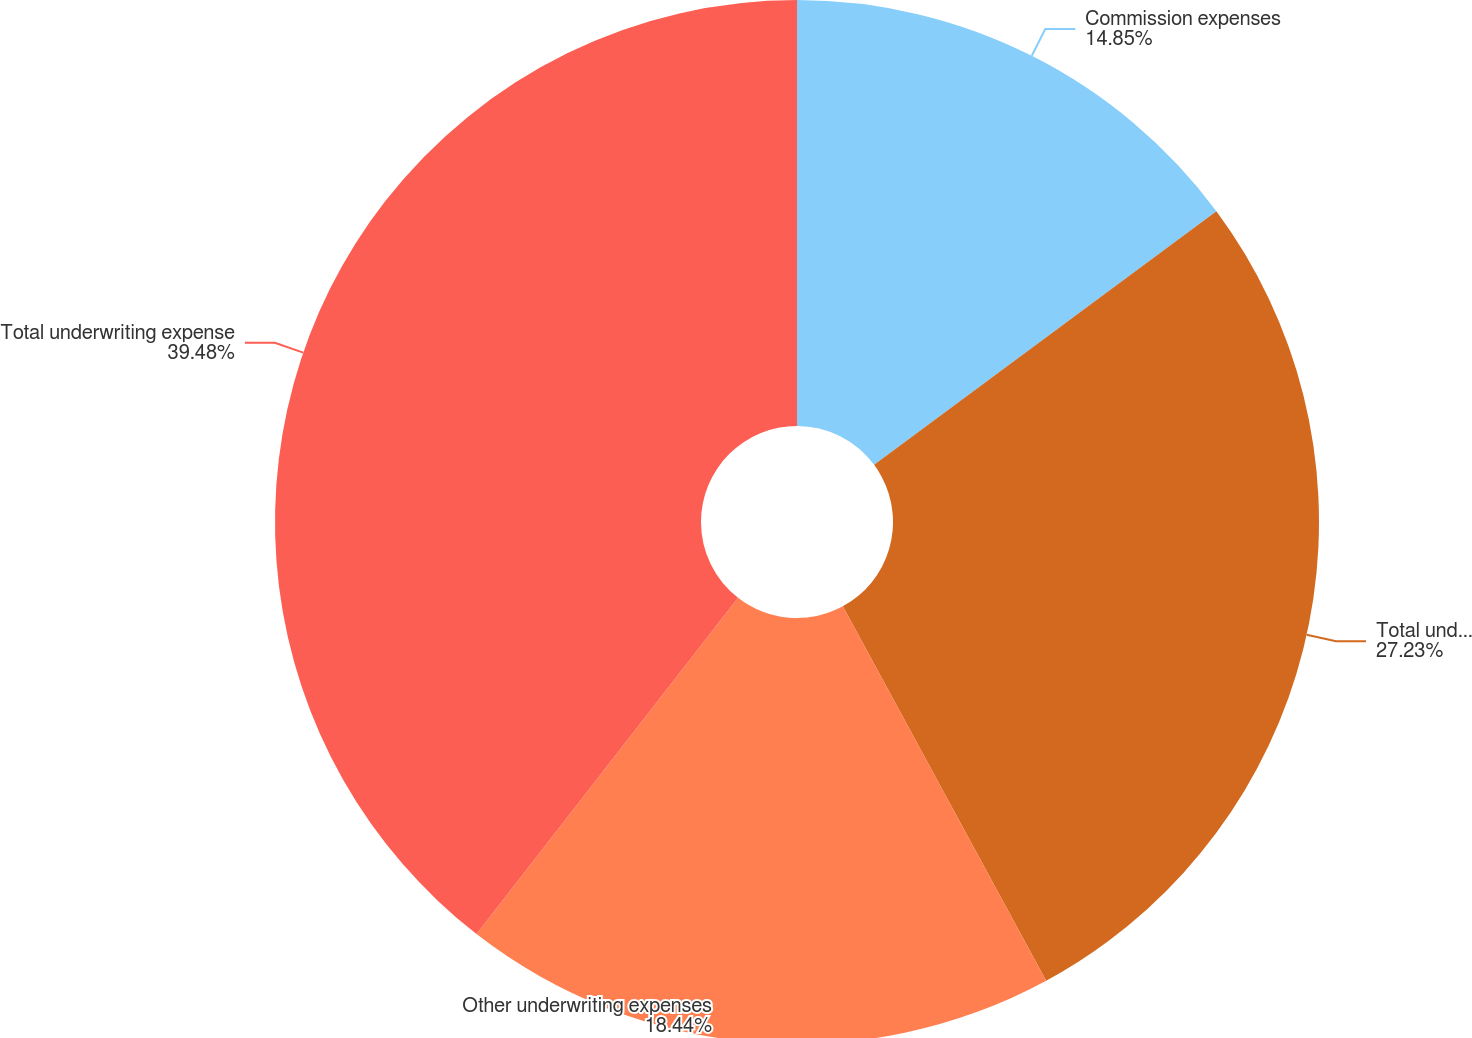Convert chart. <chart><loc_0><loc_0><loc_500><loc_500><pie_chart><fcel>Commission expenses<fcel>Total underwriting expenses<fcel>Other underwriting expenses<fcel>Total underwriting expense<nl><fcel>14.85%<fcel>27.23%<fcel>18.44%<fcel>39.48%<nl></chart> 